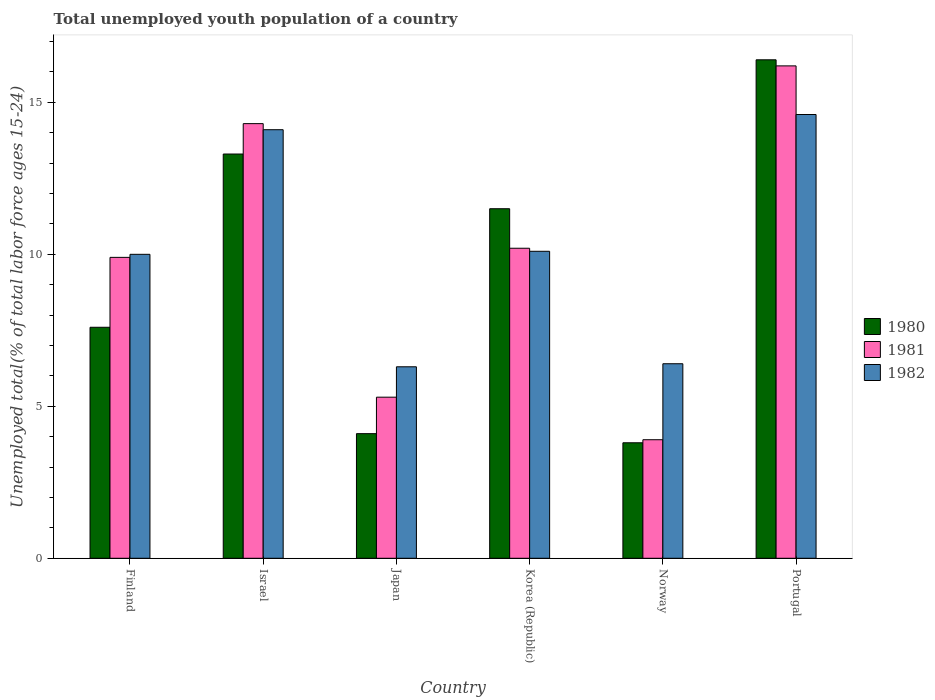How many different coloured bars are there?
Offer a terse response. 3. How many groups of bars are there?
Offer a very short reply. 6. Are the number of bars per tick equal to the number of legend labels?
Provide a short and direct response. Yes. Are the number of bars on each tick of the X-axis equal?
Your answer should be very brief. Yes. What is the label of the 3rd group of bars from the left?
Your answer should be very brief. Japan. What is the percentage of total unemployed youth population of a country in 1981 in Japan?
Offer a terse response. 5.3. Across all countries, what is the maximum percentage of total unemployed youth population of a country in 1982?
Your answer should be compact. 14.6. Across all countries, what is the minimum percentage of total unemployed youth population of a country in 1981?
Give a very brief answer. 3.9. In which country was the percentage of total unemployed youth population of a country in 1981 maximum?
Provide a short and direct response. Portugal. What is the total percentage of total unemployed youth population of a country in 1982 in the graph?
Give a very brief answer. 61.5. What is the difference between the percentage of total unemployed youth population of a country in 1980 in Japan and that in Norway?
Your answer should be very brief. 0.3. What is the difference between the percentage of total unemployed youth population of a country in 1980 in Korea (Republic) and the percentage of total unemployed youth population of a country in 1981 in Norway?
Offer a very short reply. 7.6. What is the average percentage of total unemployed youth population of a country in 1982 per country?
Offer a very short reply. 10.25. What is the difference between the percentage of total unemployed youth population of a country of/in 1981 and percentage of total unemployed youth population of a country of/in 1980 in Korea (Republic)?
Ensure brevity in your answer.  -1.3. In how many countries, is the percentage of total unemployed youth population of a country in 1980 greater than 1 %?
Offer a terse response. 6. What is the ratio of the percentage of total unemployed youth population of a country in 1981 in Japan to that in Korea (Republic)?
Your answer should be very brief. 0.52. Is the difference between the percentage of total unemployed youth population of a country in 1981 in Israel and Korea (Republic) greater than the difference between the percentage of total unemployed youth population of a country in 1980 in Israel and Korea (Republic)?
Offer a terse response. Yes. What is the difference between the highest and the second highest percentage of total unemployed youth population of a country in 1981?
Make the answer very short. 6. What is the difference between the highest and the lowest percentage of total unemployed youth population of a country in 1981?
Give a very brief answer. 12.3. In how many countries, is the percentage of total unemployed youth population of a country in 1981 greater than the average percentage of total unemployed youth population of a country in 1981 taken over all countries?
Offer a terse response. 3. What does the 1st bar from the left in Norway represents?
Provide a succinct answer. 1980. How many countries are there in the graph?
Offer a terse response. 6. What is the difference between two consecutive major ticks on the Y-axis?
Ensure brevity in your answer.  5. Does the graph contain any zero values?
Your response must be concise. No. Does the graph contain grids?
Your response must be concise. No. How many legend labels are there?
Provide a succinct answer. 3. What is the title of the graph?
Offer a very short reply. Total unemployed youth population of a country. Does "1995" appear as one of the legend labels in the graph?
Make the answer very short. No. What is the label or title of the X-axis?
Provide a succinct answer. Country. What is the label or title of the Y-axis?
Make the answer very short. Unemployed total(% of total labor force ages 15-24). What is the Unemployed total(% of total labor force ages 15-24) of 1980 in Finland?
Keep it short and to the point. 7.6. What is the Unemployed total(% of total labor force ages 15-24) in 1981 in Finland?
Your response must be concise. 9.9. What is the Unemployed total(% of total labor force ages 15-24) in 1980 in Israel?
Your response must be concise. 13.3. What is the Unemployed total(% of total labor force ages 15-24) of 1981 in Israel?
Make the answer very short. 14.3. What is the Unemployed total(% of total labor force ages 15-24) of 1982 in Israel?
Provide a short and direct response. 14.1. What is the Unemployed total(% of total labor force ages 15-24) of 1980 in Japan?
Keep it short and to the point. 4.1. What is the Unemployed total(% of total labor force ages 15-24) in 1981 in Japan?
Give a very brief answer. 5.3. What is the Unemployed total(% of total labor force ages 15-24) of 1982 in Japan?
Provide a succinct answer. 6.3. What is the Unemployed total(% of total labor force ages 15-24) in 1981 in Korea (Republic)?
Offer a terse response. 10.2. What is the Unemployed total(% of total labor force ages 15-24) of 1982 in Korea (Republic)?
Your answer should be compact. 10.1. What is the Unemployed total(% of total labor force ages 15-24) of 1980 in Norway?
Make the answer very short. 3.8. What is the Unemployed total(% of total labor force ages 15-24) of 1981 in Norway?
Provide a short and direct response. 3.9. What is the Unemployed total(% of total labor force ages 15-24) of 1982 in Norway?
Offer a very short reply. 6.4. What is the Unemployed total(% of total labor force ages 15-24) of 1980 in Portugal?
Offer a very short reply. 16.4. What is the Unemployed total(% of total labor force ages 15-24) in 1981 in Portugal?
Offer a terse response. 16.2. What is the Unemployed total(% of total labor force ages 15-24) of 1982 in Portugal?
Provide a short and direct response. 14.6. Across all countries, what is the maximum Unemployed total(% of total labor force ages 15-24) of 1980?
Make the answer very short. 16.4. Across all countries, what is the maximum Unemployed total(% of total labor force ages 15-24) in 1981?
Your answer should be compact. 16.2. Across all countries, what is the maximum Unemployed total(% of total labor force ages 15-24) in 1982?
Provide a succinct answer. 14.6. Across all countries, what is the minimum Unemployed total(% of total labor force ages 15-24) in 1980?
Give a very brief answer. 3.8. Across all countries, what is the minimum Unemployed total(% of total labor force ages 15-24) in 1981?
Make the answer very short. 3.9. Across all countries, what is the minimum Unemployed total(% of total labor force ages 15-24) in 1982?
Your answer should be compact. 6.3. What is the total Unemployed total(% of total labor force ages 15-24) of 1980 in the graph?
Your answer should be very brief. 56.7. What is the total Unemployed total(% of total labor force ages 15-24) of 1981 in the graph?
Provide a short and direct response. 59.8. What is the total Unemployed total(% of total labor force ages 15-24) in 1982 in the graph?
Provide a short and direct response. 61.5. What is the difference between the Unemployed total(% of total labor force ages 15-24) of 1980 in Finland and that in Israel?
Your answer should be compact. -5.7. What is the difference between the Unemployed total(% of total labor force ages 15-24) of 1981 in Finland and that in Israel?
Your answer should be compact. -4.4. What is the difference between the Unemployed total(% of total labor force ages 15-24) in 1982 in Finland and that in Japan?
Your response must be concise. 3.7. What is the difference between the Unemployed total(% of total labor force ages 15-24) in 1980 in Finland and that in Korea (Republic)?
Ensure brevity in your answer.  -3.9. What is the difference between the Unemployed total(% of total labor force ages 15-24) of 1981 in Finland and that in Korea (Republic)?
Your response must be concise. -0.3. What is the difference between the Unemployed total(% of total labor force ages 15-24) of 1980 in Finland and that in Norway?
Your answer should be compact. 3.8. What is the difference between the Unemployed total(% of total labor force ages 15-24) of 1981 in Finland and that in Norway?
Your answer should be very brief. 6. What is the difference between the Unemployed total(% of total labor force ages 15-24) in 1982 in Finland and that in Norway?
Provide a succinct answer. 3.6. What is the difference between the Unemployed total(% of total labor force ages 15-24) in 1980 in Finland and that in Portugal?
Your answer should be compact. -8.8. What is the difference between the Unemployed total(% of total labor force ages 15-24) of 1982 in Finland and that in Portugal?
Provide a short and direct response. -4.6. What is the difference between the Unemployed total(% of total labor force ages 15-24) of 1982 in Israel and that in Japan?
Your answer should be compact. 7.8. What is the difference between the Unemployed total(% of total labor force ages 15-24) in 1981 in Israel and that in Korea (Republic)?
Offer a very short reply. 4.1. What is the difference between the Unemployed total(% of total labor force ages 15-24) in 1982 in Israel and that in Korea (Republic)?
Your answer should be very brief. 4. What is the difference between the Unemployed total(% of total labor force ages 15-24) of 1981 in Israel and that in Norway?
Your answer should be compact. 10.4. What is the difference between the Unemployed total(% of total labor force ages 15-24) of 1981 in Israel and that in Portugal?
Offer a terse response. -1.9. What is the difference between the Unemployed total(% of total labor force ages 15-24) in 1980 in Japan and that in Korea (Republic)?
Provide a succinct answer. -7.4. What is the difference between the Unemployed total(% of total labor force ages 15-24) of 1982 in Japan and that in Korea (Republic)?
Keep it short and to the point. -3.8. What is the difference between the Unemployed total(% of total labor force ages 15-24) in 1980 in Japan and that in Norway?
Offer a terse response. 0.3. What is the difference between the Unemployed total(% of total labor force ages 15-24) in 1980 in Korea (Republic) and that in Norway?
Your answer should be compact. 7.7. What is the difference between the Unemployed total(% of total labor force ages 15-24) of 1980 in Korea (Republic) and that in Portugal?
Your response must be concise. -4.9. What is the difference between the Unemployed total(% of total labor force ages 15-24) in 1981 in Korea (Republic) and that in Portugal?
Make the answer very short. -6. What is the difference between the Unemployed total(% of total labor force ages 15-24) in 1982 in Korea (Republic) and that in Portugal?
Provide a succinct answer. -4.5. What is the difference between the Unemployed total(% of total labor force ages 15-24) of 1982 in Norway and that in Portugal?
Keep it short and to the point. -8.2. What is the difference between the Unemployed total(% of total labor force ages 15-24) of 1980 in Finland and the Unemployed total(% of total labor force ages 15-24) of 1982 in Israel?
Make the answer very short. -6.5. What is the difference between the Unemployed total(% of total labor force ages 15-24) in 1981 in Finland and the Unemployed total(% of total labor force ages 15-24) in 1982 in Israel?
Provide a short and direct response. -4.2. What is the difference between the Unemployed total(% of total labor force ages 15-24) in 1980 in Finland and the Unemployed total(% of total labor force ages 15-24) in 1981 in Japan?
Your answer should be compact. 2.3. What is the difference between the Unemployed total(% of total labor force ages 15-24) in 1980 in Finland and the Unemployed total(% of total labor force ages 15-24) in 1981 in Norway?
Offer a very short reply. 3.7. What is the difference between the Unemployed total(% of total labor force ages 15-24) of 1980 in Israel and the Unemployed total(% of total labor force ages 15-24) of 1981 in Japan?
Give a very brief answer. 8. What is the difference between the Unemployed total(% of total labor force ages 15-24) of 1980 in Israel and the Unemployed total(% of total labor force ages 15-24) of 1982 in Japan?
Your answer should be compact. 7. What is the difference between the Unemployed total(% of total labor force ages 15-24) in 1981 in Israel and the Unemployed total(% of total labor force ages 15-24) in 1982 in Japan?
Offer a terse response. 8. What is the difference between the Unemployed total(% of total labor force ages 15-24) in 1980 in Israel and the Unemployed total(% of total labor force ages 15-24) in 1981 in Korea (Republic)?
Provide a succinct answer. 3.1. What is the difference between the Unemployed total(% of total labor force ages 15-24) of 1981 in Israel and the Unemployed total(% of total labor force ages 15-24) of 1982 in Korea (Republic)?
Your answer should be compact. 4.2. What is the difference between the Unemployed total(% of total labor force ages 15-24) of 1981 in Israel and the Unemployed total(% of total labor force ages 15-24) of 1982 in Norway?
Keep it short and to the point. 7.9. What is the difference between the Unemployed total(% of total labor force ages 15-24) in 1980 in Israel and the Unemployed total(% of total labor force ages 15-24) in 1981 in Portugal?
Provide a succinct answer. -2.9. What is the difference between the Unemployed total(% of total labor force ages 15-24) of 1980 in Israel and the Unemployed total(% of total labor force ages 15-24) of 1982 in Portugal?
Give a very brief answer. -1.3. What is the difference between the Unemployed total(% of total labor force ages 15-24) of 1980 in Japan and the Unemployed total(% of total labor force ages 15-24) of 1981 in Korea (Republic)?
Provide a succinct answer. -6.1. What is the difference between the Unemployed total(% of total labor force ages 15-24) of 1981 in Japan and the Unemployed total(% of total labor force ages 15-24) of 1982 in Korea (Republic)?
Give a very brief answer. -4.8. What is the difference between the Unemployed total(% of total labor force ages 15-24) of 1980 in Japan and the Unemployed total(% of total labor force ages 15-24) of 1981 in Norway?
Provide a short and direct response. 0.2. What is the difference between the Unemployed total(% of total labor force ages 15-24) in 1981 in Japan and the Unemployed total(% of total labor force ages 15-24) in 1982 in Norway?
Make the answer very short. -1.1. What is the difference between the Unemployed total(% of total labor force ages 15-24) in 1980 in Japan and the Unemployed total(% of total labor force ages 15-24) in 1982 in Portugal?
Ensure brevity in your answer.  -10.5. What is the difference between the Unemployed total(% of total labor force ages 15-24) in 1980 in Korea (Republic) and the Unemployed total(% of total labor force ages 15-24) in 1981 in Norway?
Your answer should be compact. 7.6. What is the difference between the Unemployed total(% of total labor force ages 15-24) in 1980 in Korea (Republic) and the Unemployed total(% of total labor force ages 15-24) in 1981 in Portugal?
Ensure brevity in your answer.  -4.7. What is the difference between the Unemployed total(% of total labor force ages 15-24) of 1981 in Korea (Republic) and the Unemployed total(% of total labor force ages 15-24) of 1982 in Portugal?
Provide a succinct answer. -4.4. What is the difference between the Unemployed total(% of total labor force ages 15-24) in 1980 in Norway and the Unemployed total(% of total labor force ages 15-24) in 1981 in Portugal?
Your response must be concise. -12.4. What is the difference between the Unemployed total(% of total labor force ages 15-24) in 1980 in Norway and the Unemployed total(% of total labor force ages 15-24) in 1982 in Portugal?
Provide a short and direct response. -10.8. What is the average Unemployed total(% of total labor force ages 15-24) in 1980 per country?
Ensure brevity in your answer.  9.45. What is the average Unemployed total(% of total labor force ages 15-24) of 1981 per country?
Keep it short and to the point. 9.97. What is the average Unemployed total(% of total labor force ages 15-24) of 1982 per country?
Ensure brevity in your answer.  10.25. What is the difference between the Unemployed total(% of total labor force ages 15-24) in 1980 and Unemployed total(% of total labor force ages 15-24) in 1982 in Finland?
Make the answer very short. -2.4. What is the difference between the Unemployed total(% of total labor force ages 15-24) of 1981 and Unemployed total(% of total labor force ages 15-24) of 1982 in Israel?
Your response must be concise. 0.2. What is the difference between the Unemployed total(% of total labor force ages 15-24) of 1980 and Unemployed total(% of total labor force ages 15-24) of 1981 in Japan?
Your response must be concise. -1.2. What is the difference between the Unemployed total(% of total labor force ages 15-24) in 1980 and Unemployed total(% of total labor force ages 15-24) in 1982 in Japan?
Your answer should be very brief. -2.2. What is the difference between the Unemployed total(% of total labor force ages 15-24) of 1981 and Unemployed total(% of total labor force ages 15-24) of 1982 in Korea (Republic)?
Provide a succinct answer. 0.1. What is the difference between the Unemployed total(% of total labor force ages 15-24) in 1980 and Unemployed total(% of total labor force ages 15-24) in 1982 in Norway?
Keep it short and to the point. -2.6. What is the difference between the Unemployed total(% of total labor force ages 15-24) in 1980 and Unemployed total(% of total labor force ages 15-24) in 1981 in Portugal?
Give a very brief answer. 0.2. What is the difference between the Unemployed total(% of total labor force ages 15-24) in 1980 and Unemployed total(% of total labor force ages 15-24) in 1982 in Portugal?
Offer a very short reply. 1.8. What is the difference between the Unemployed total(% of total labor force ages 15-24) of 1981 and Unemployed total(% of total labor force ages 15-24) of 1982 in Portugal?
Provide a short and direct response. 1.6. What is the ratio of the Unemployed total(% of total labor force ages 15-24) in 1980 in Finland to that in Israel?
Give a very brief answer. 0.57. What is the ratio of the Unemployed total(% of total labor force ages 15-24) in 1981 in Finland to that in Israel?
Offer a very short reply. 0.69. What is the ratio of the Unemployed total(% of total labor force ages 15-24) in 1982 in Finland to that in Israel?
Offer a very short reply. 0.71. What is the ratio of the Unemployed total(% of total labor force ages 15-24) of 1980 in Finland to that in Japan?
Your answer should be very brief. 1.85. What is the ratio of the Unemployed total(% of total labor force ages 15-24) in 1981 in Finland to that in Japan?
Your answer should be very brief. 1.87. What is the ratio of the Unemployed total(% of total labor force ages 15-24) in 1982 in Finland to that in Japan?
Ensure brevity in your answer.  1.59. What is the ratio of the Unemployed total(% of total labor force ages 15-24) of 1980 in Finland to that in Korea (Republic)?
Provide a short and direct response. 0.66. What is the ratio of the Unemployed total(% of total labor force ages 15-24) in 1981 in Finland to that in Korea (Republic)?
Provide a succinct answer. 0.97. What is the ratio of the Unemployed total(% of total labor force ages 15-24) of 1981 in Finland to that in Norway?
Offer a terse response. 2.54. What is the ratio of the Unemployed total(% of total labor force ages 15-24) in 1982 in Finland to that in Norway?
Offer a terse response. 1.56. What is the ratio of the Unemployed total(% of total labor force ages 15-24) in 1980 in Finland to that in Portugal?
Your answer should be very brief. 0.46. What is the ratio of the Unemployed total(% of total labor force ages 15-24) in 1981 in Finland to that in Portugal?
Your answer should be very brief. 0.61. What is the ratio of the Unemployed total(% of total labor force ages 15-24) in 1982 in Finland to that in Portugal?
Make the answer very short. 0.68. What is the ratio of the Unemployed total(% of total labor force ages 15-24) of 1980 in Israel to that in Japan?
Provide a succinct answer. 3.24. What is the ratio of the Unemployed total(% of total labor force ages 15-24) in 1981 in Israel to that in Japan?
Your answer should be compact. 2.7. What is the ratio of the Unemployed total(% of total labor force ages 15-24) of 1982 in Israel to that in Japan?
Your answer should be very brief. 2.24. What is the ratio of the Unemployed total(% of total labor force ages 15-24) of 1980 in Israel to that in Korea (Republic)?
Make the answer very short. 1.16. What is the ratio of the Unemployed total(% of total labor force ages 15-24) in 1981 in Israel to that in Korea (Republic)?
Your answer should be compact. 1.4. What is the ratio of the Unemployed total(% of total labor force ages 15-24) in 1982 in Israel to that in Korea (Republic)?
Provide a succinct answer. 1.4. What is the ratio of the Unemployed total(% of total labor force ages 15-24) of 1981 in Israel to that in Norway?
Offer a terse response. 3.67. What is the ratio of the Unemployed total(% of total labor force ages 15-24) in 1982 in Israel to that in Norway?
Offer a very short reply. 2.2. What is the ratio of the Unemployed total(% of total labor force ages 15-24) of 1980 in Israel to that in Portugal?
Your answer should be very brief. 0.81. What is the ratio of the Unemployed total(% of total labor force ages 15-24) of 1981 in Israel to that in Portugal?
Offer a terse response. 0.88. What is the ratio of the Unemployed total(% of total labor force ages 15-24) in 1982 in Israel to that in Portugal?
Your response must be concise. 0.97. What is the ratio of the Unemployed total(% of total labor force ages 15-24) in 1980 in Japan to that in Korea (Republic)?
Your response must be concise. 0.36. What is the ratio of the Unemployed total(% of total labor force ages 15-24) of 1981 in Japan to that in Korea (Republic)?
Provide a succinct answer. 0.52. What is the ratio of the Unemployed total(% of total labor force ages 15-24) in 1982 in Japan to that in Korea (Republic)?
Give a very brief answer. 0.62. What is the ratio of the Unemployed total(% of total labor force ages 15-24) in 1980 in Japan to that in Norway?
Keep it short and to the point. 1.08. What is the ratio of the Unemployed total(% of total labor force ages 15-24) of 1981 in Japan to that in Norway?
Keep it short and to the point. 1.36. What is the ratio of the Unemployed total(% of total labor force ages 15-24) of 1982 in Japan to that in Norway?
Provide a short and direct response. 0.98. What is the ratio of the Unemployed total(% of total labor force ages 15-24) of 1980 in Japan to that in Portugal?
Keep it short and to the point. 0.25. What is the ratio of the Unemployed total(% of total labor force ages 15-24) in 1981 in Japan to that in Portugal?
Offer a very short reply. 0.33. What is the ratio of the Unemployed total(% of total labor force ages 15-24) in 1982 in Japan to that in Portugal?
Make the answer very short. 0.43. What is the ratio of the Unemployed total(% of total labor force ages 15-24) of 1980 in Korea (Republic) to that in Norway?
Give a very brief answer. 3.03. What is the ratio of the Unemployed total(% of total labor force ages 15-24) in 1981 in Korea (Republic) to that in Norway?
Offer a terse response. 2.62. What is the ratio of the Unemployed total(% of total labor force ages 15-24) in 1982 in Korea (Republic) to that in Norway?
Your response must be concise. 1.58. What is the ratio of the Unemployed total(% of total labor force ages 15-24) of 1980 in Korea (Republic) to that in Portugal?
Your answer should be compact. 0.7. What is the ratio of the Unemployed total(% of total labor force ages 15-24) in 1981 in Korea (Republic) to that in Portugal?
Provide a succinct answer. 0.63. What is the ratio of the Unemployed total(% of total labor force ages 15-24) in 1982 in Korea (Republic) to that in Portugal?
Your response must be concise. 0.69. What is the ratio of the Unemployed total(% of total labor force ages 15-24) in 1980 in Norway to that in Portugal?
Your answer should be compact. 0.23. What is the ratio of the Unemployed total(% of total labor force ages 15-24) in 1981 in Norway to that in Portugal?
Your response must be concise. 0.24. What is the ratio of the Unemployed total(% of total labor force ages 15-24) in 1982 in Norway to that in Portugal?
Make the answer very short. 0.44. What is the difference between the highest and the second highest Unemployed total(% of total labor force ages 15-24) in 1981?
Provide a short and direct response. 1.9. What is the difference between the highest and the second highest Unemployed total(% of total labor force ages 15-24) in 1982?
Provide a succinct answer. 0.5. What is the difference between the highest and the lowest Unemployed total(% of total labor force ages 15-24) of 1981?
Ensure brevity in your answer.  12.3. What is the difference between the highest and the lowest Unemployed total(% of total labor force ages 15-24) in 1982?
Offer a terse response. 8.3. 